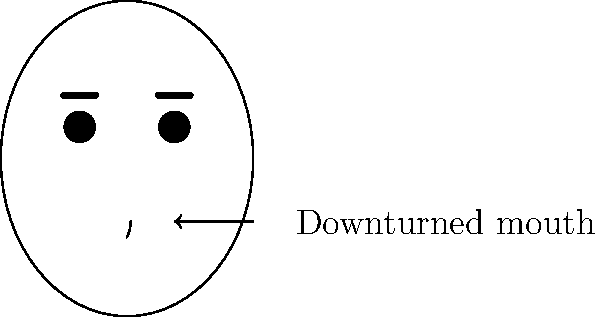As a language specialist interpreting witness sketches, what emotion is most likely being conveyed by the facial expression in this image, particularly focusing on the indicated feature? To interpret the emotion conveyed in this witness sketch, we need to analyze the key facial features:

1. Mouth: The most prominent feature, indicated by the arrow, is a downturned mouth. This is typically associated with negative emotions.

2. Eyes: The eyes are neutral, not providing additional emotional context.

3. Eyebrows: The eyebrows are straight, not adding significant emotional information.

4. Overall expression: The combination of neutral eyes and eyebrows with a distinctly downturned mouth suggests sadness or unhappiness.

5. Context: In witness testimonies, a sad expression could indicate distress, trauma, or negative emotions associated with recalling an event.

Given the emphasis on the downturned mouth and the lack of other strong emotional indicators, the most likely emotion being conveyed is sadness.
Answer: Sadness 